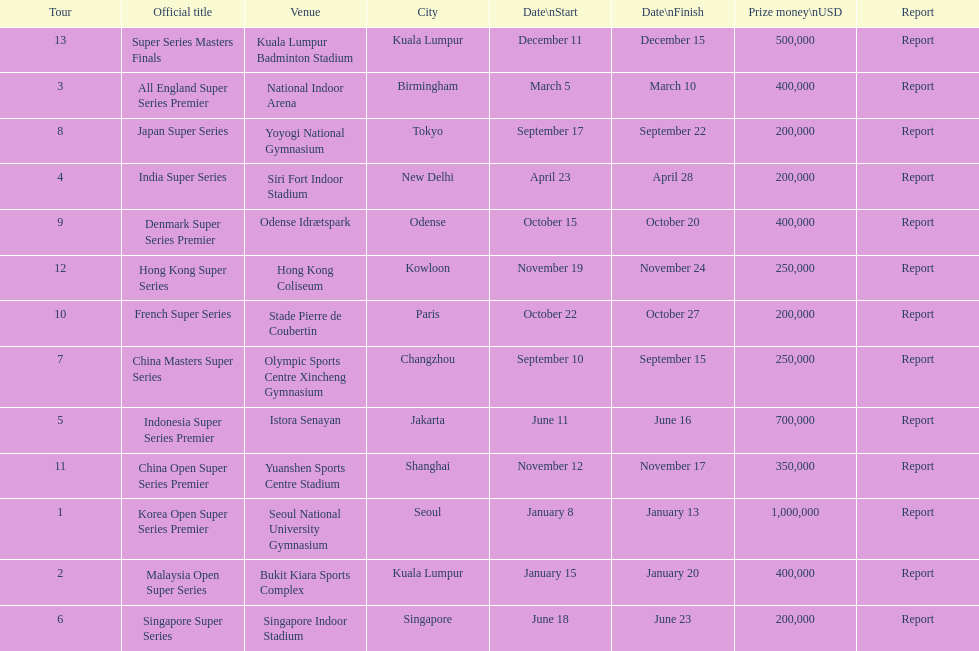How many days does the japan super series last? 5. 